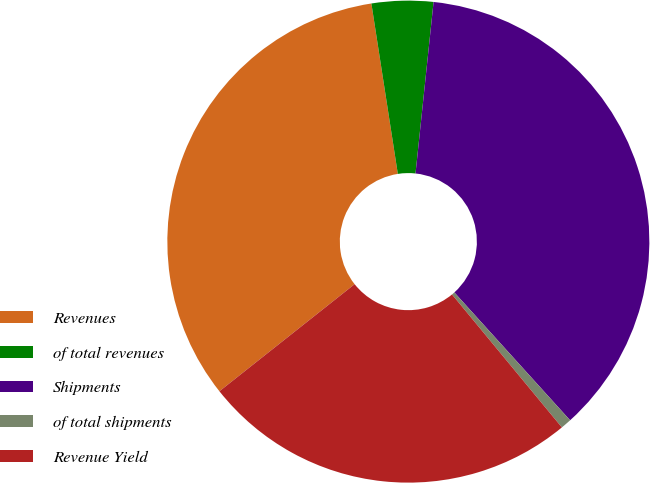Convert chart to OTSL. <chart><loc_0><loc_0><loc_500><loc_500><pie_chart><fcel>Revenues<fcel>of total revenues<fcel>Shipments<fcel>of total shipments<fcel>Revenue Yield<nl><fcel>33.21%<fcel>4.12%<fcel>36.62%<fcel>0.72%<fcel>25.33%<nl></chart> 